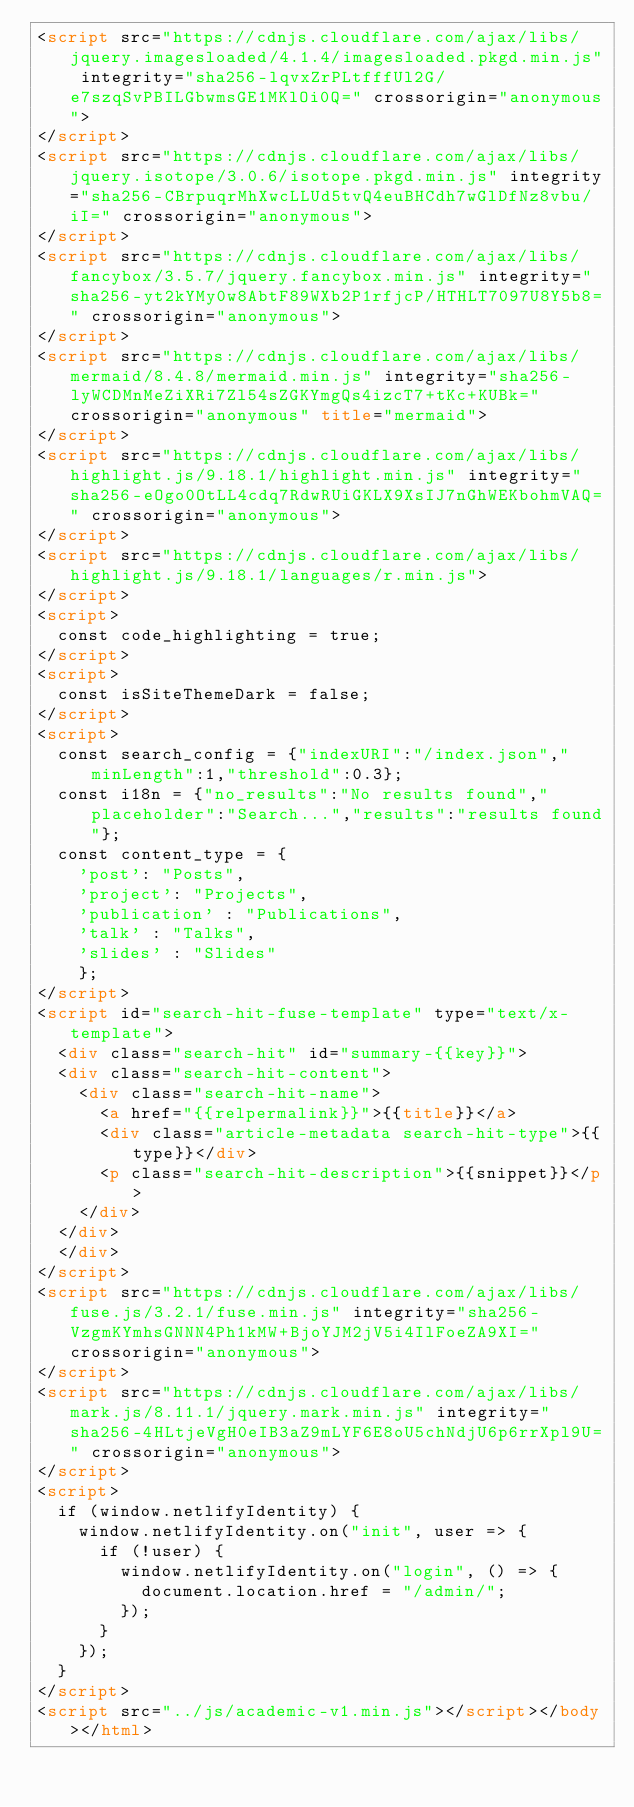Convert code to text. <code><loc_0><loc_0><loc_500><loc_500><_HTML_><script src="https://cdnjs.cloudflare.com/ajax/libs/jquery.imagesloaded/4.1.4/imagesloaded.pkgd.min.js" integrity="sha256-lqvxZrPLtfffUl2G/e7szqSvPBILGbwmsGE1MKlOi0Q=" crossorigin="anonymous">
</script>
<script src="https://cdnjs.cloudflare.com/ajax/libs/jquery.isotope/3.0.6/isotope.pkgd.min.js" integrity="sha256-CBrpuqrMhXwcLLUd5tvQ4euBHCdh7wGlDfNz8vbu/iI=" crossorigin="anonymous">
</script>
<script src="https://cdnjs.cloudflare.com/ajax/libs/fancybox/3.5.7/jquery.fancybox.min.js" integrity="sha256-yt2kYMy0w8AbtF89WXb2P1rfjcP/HTHLT7097U8Y5b8=" crossorigin="anonymous">
</script>
<script src="https://cdnjs.cloudflare.com/ajax/libs/mermaid/8.4.8/mermaid.min.js" integrity="sha256-lyWCDMnMeZiXRi7Zl54sZGKYmgQs4izcT7+tKc+KUBk=" crossorigin="anonymous" title="mermaid">
</script>
<script src="https://cdnjs.cloudflare.com/ajax/libs/highlight.js/9.18.1/highlight.min.js" integrity="sha256-eOgo0OtLL4cdq7RdwRUiGKLX9XsIJ7nGhWEKbohmVAQ=" crossorigin="anonymous">
</script>
<script src="https://cdnjs.cloudflare.com/ajax/libs/highlight.js/9.18.1/languages/r.min.js">
</script>
<script>
	const code_highlighting = true;
</script>
<script>
	const isSiteThemeDark = false;
</script>
<script>
	const search_config = {"indexURI":"/index.json","minLength":1,"threshold":0.3};
	const i18n = {"no_results":"No results found","placeholder":"Search...","results":"results found"};
	const content_type = {
	  'post': "Posts",
	  'project': "Projects",
	  'publication' : "Publications",
	  'talk' : "Talks",
	  'slides' : "Slides"
	  };
</script>
<script id="search-hit-fuse-template" type="text/x-template">
	<div class="search-hit" id="summary-{{key}}">
	<div class="search-hit-content">
	  <div class="search-hit-name">
	    <a href="{{relpermalink}}">{{title}}</a>
	    <div class="article-metadata search-hit-type">{{type}}</div>
	    <p class="search-hit-description">{{snippet}}</p>
	  </div>
	</div>
	</div>
</script>
<script src="https://cdnjs.cloudflare.com/ajax/libs/fuse.js/3.2.1/fuse.min.js" integrity="sha256-VzgmKYmhsGNNN4Ph1kMW+BjoYJM2jV5i4IlFoeZA9XI=" crossorigin="anonymous">
</script>
<script src="https://cdnjs.cloudflare.com/ajax/libs/mark.js/8.11.1/jquery.mark.min.js" integrity="sha256-4HLtjeVgH0eIB3aZ9mLYF6E8oU5chNdjU6p6rrXpl9U=" crossorigin="anonymous">
</script>
<script>
	if (window.netlifyIdentity) {
	  window.netlifyIdentity.on("init", user => {
	    if (!user) {
	      window.netlifyIdentity.on("login", () => {
	        document.location.href = "/admin/";
	      });
	    }
	  });
	}
</script>
<script src="../js/academic-v1.min.js"></script></body></html>
</code> 